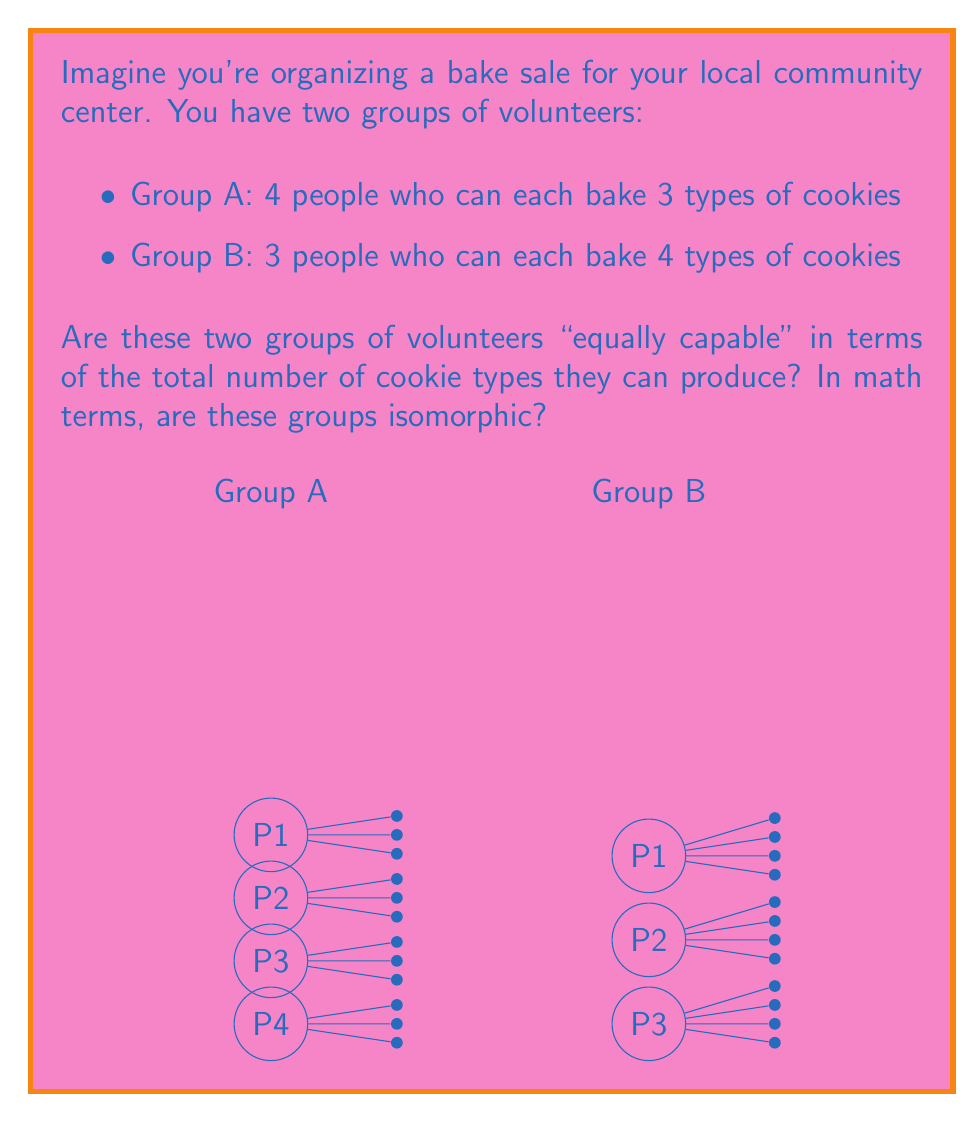What is the answer to this math problem? To determine if two groups are isomorphic, we need to check if there's a one-to-one correspondence between their elements that preserves the group operation. In this case, we're looking at the total number of cookie types each group can produce.

Let's break it down step-by-step:

1) First, let's calculate the total number of cookie types for each group:

   Group A: $4 \text{ people} \times 3 \text{ types} = 12 \text{ total types}$
   Group B: $3 \text{ people} \times 4 \text{ types} = 12 \text{ total types}$

2) We see that both groups can produce the same total number of cookie types. This is a good start, but it's not enough to prove isomorphism.

3) To be isomorphic, we need to find a one-to-one correspondence between the elements of the groups that preserves the group operation. In this case, the "operation" is the ability to produce cookie types.

4) We can map the elements as follows:
   - Each person in Group A who can make 3 types of cookies corresponds to 3/4 of a person in Group B.
   - Each person in Group B who can make 4 types of cookies corresponds to 4/3 of a person in Group A.

5) This mapping preserves the "operation" (cookie-making ability) and creates a one-to-one correspondence between the elements of the two groups.

Therefore, these two groups are indeed isomorphic in terms of their cookie-making capabilities.

In mathematical terms, we could represent this as an isomorphism $\phi$ from Group A to Group B:

$\phi: A \to B$ where $\phi(a) = \frac{3}{4}a$ for $a \in A$

The inverse function would be:

$\phi^{-1}: B \to A$ where $\phi^{-1}(b) = \frac{4}{3}b$ for $b \in B$

These functions preserve the group operation (multiplication in this case) and form a bijection between the two groups.
Answer: Yes, the groups are isomorphic. 